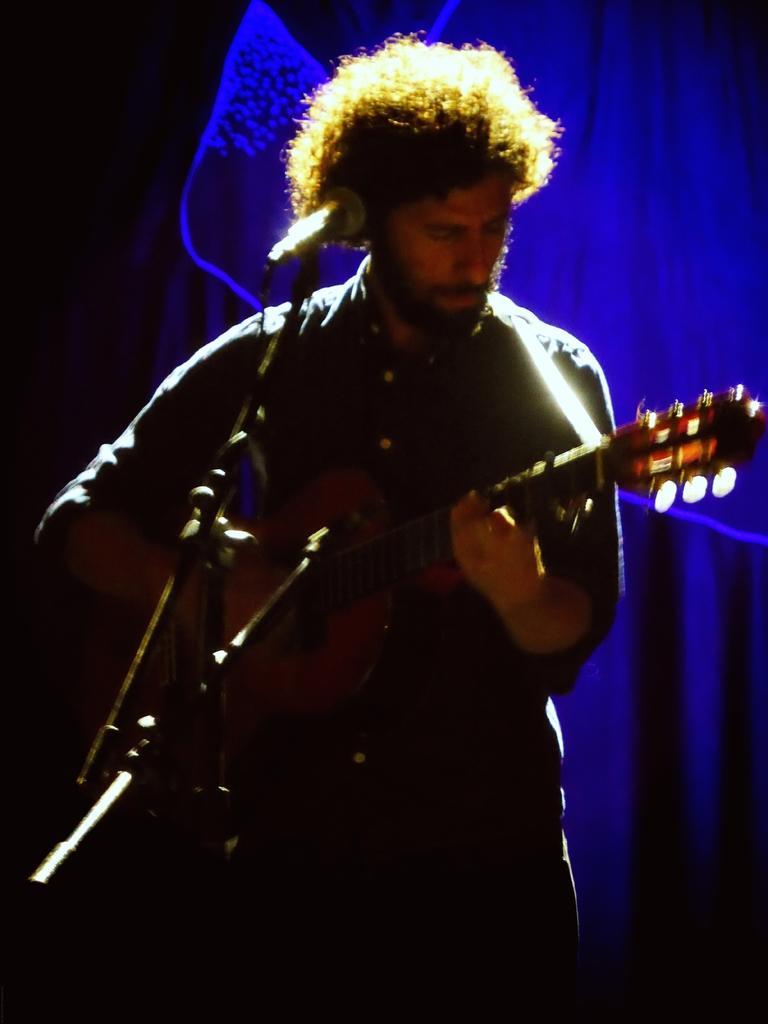Can you describe this image briefly? In this picture I can see a man standing and holding a guitar, there is a mike with a mike stand , and in the background there is a cloth. 